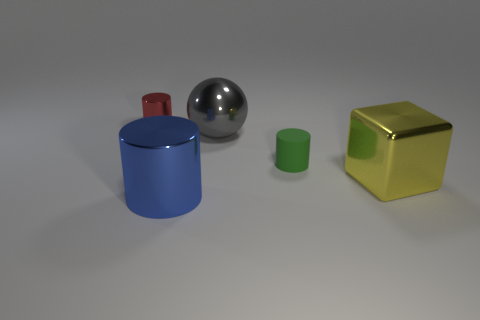Subtract all blocks. How many objects are left? 4 Add 4 small rubber things. How many objects exist? 9 Subtract all cyan shiny things. Subtract all big blue metal cylinders. How many objects are left? 4 Add 3 small green matte cylinders. How many small green matte cylinders are left? 4 Add 4 green matte cubes. How many green matte cubes exist? 4 Subtract 0 cyan blocks. How many objects are left? 5 